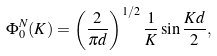<formula> <loc_0><loc_0><loc_500><loc_500>\Phi _ { 0 } ^ { N } ( K ) = \left ( \frac { 2 } { \pi d } \right ) ^ { 1 / 2 } \frac { 1 } { K } \sin \frac { K d } { 2 } ,</formula> 